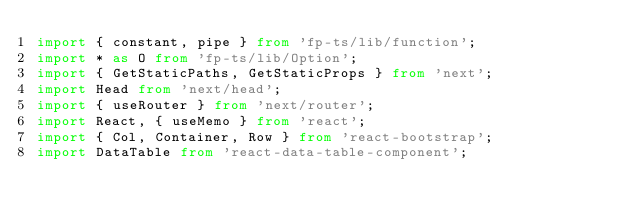<code> <loc_0><loc_0><loc_500><loc_500><_TypeScript_>import { constant, pipe } from 'fp-ts/lib/function';
import * as O from 'fp-ts/lib/Option';
import { GetStaticPaths, GetStaticProps } from 'next';
import Head from 'next/head';
import { useRouter } from 'next/router';
import React, { useMemo } from 'react';
import { Col, Container, Row } from 'react-bootstrap';
import DataTable from 'react-data-table-component';</code> 